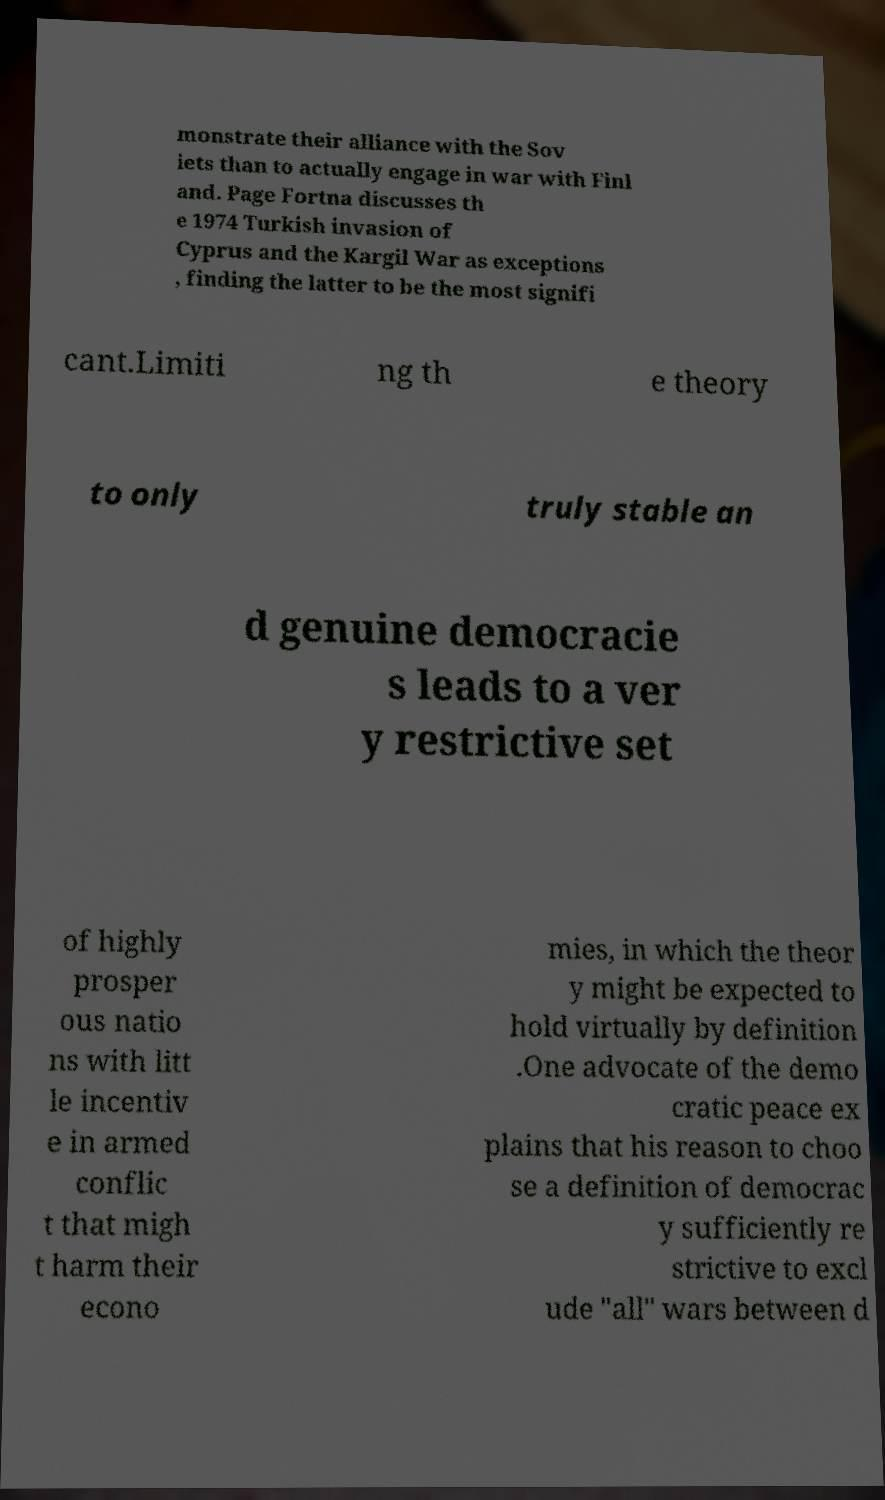Please read and relay the text visible in this image. What does it say? monstrate their alliance with the Sov iets than to actually engage in war with Finl and. Page Fortna discusses th e 1974 Turkish invasion of Cyprus and the Kargil War as exceptions , finding the latter to be the most signifi cant.Limiti ng th e theory to only truly stable an d genuine democracie s leads to a ver y restrictive set of highly prosper ous natio ns with litt le incentiv e in armed conflic t that migh t harm their econo mies, in which the theor y might be expected to hold virtually by definition .One advocate of the demo cratic peace ex plains that his reason to choo se a definition of democrac y sufficiently re strictive to excl ude "all" wars between d 